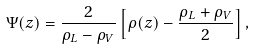Convert formula to latex. <formula><loc_0><loc_0><loc_500><loc_500>\Psi ( z ) = \frac { 2 } { \rho _ { L } - \rho _ { V } } \left [ \rho ( z ) - \frac { \rho _ { L } + \rho _ { V } } { 2 } \right ] ,</formula> 